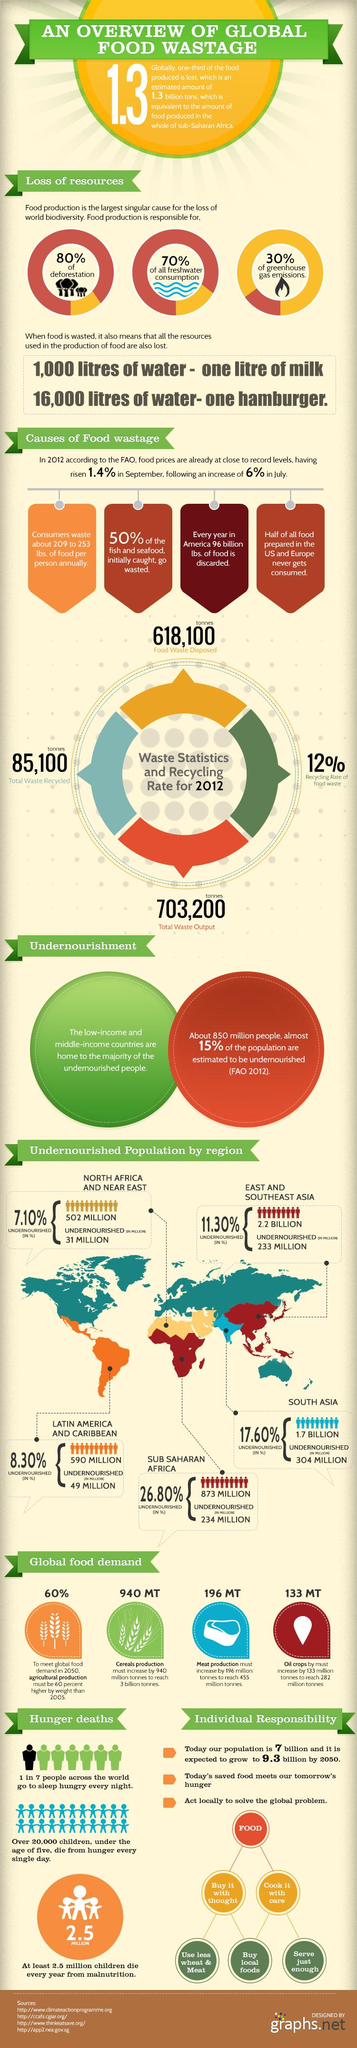Identify some key points in this picture. By the year 2050, the target for cereals production is to reach 3 billion metric tons. In North Africa and the Near East, as well as in Sub-Saharan Africa, a total of 265 million people are suffering from undernourishment. According to research, half of the food items consumed globally are wasted, with fish and seafood being significant contributors to this waste. The report indicates that in order to address the current climate crisis, two items must be reduced in their consumption: wheat and meat. In 2050, it is estimated that approximately 282 million tonnes of oil crops will be required. 